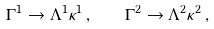<formula> <loc_0><loc_0><loc_500><loc_500>\Gamma ^ { 1 } \rightarrow \Lambda ^ { 1 } \kappa ^ { 1 } \, , \quad \Gamma ^ { 2 } \rightarrow \Lambda ^ { 2 } \kappa ^ { 2 } \, ,</formula> 